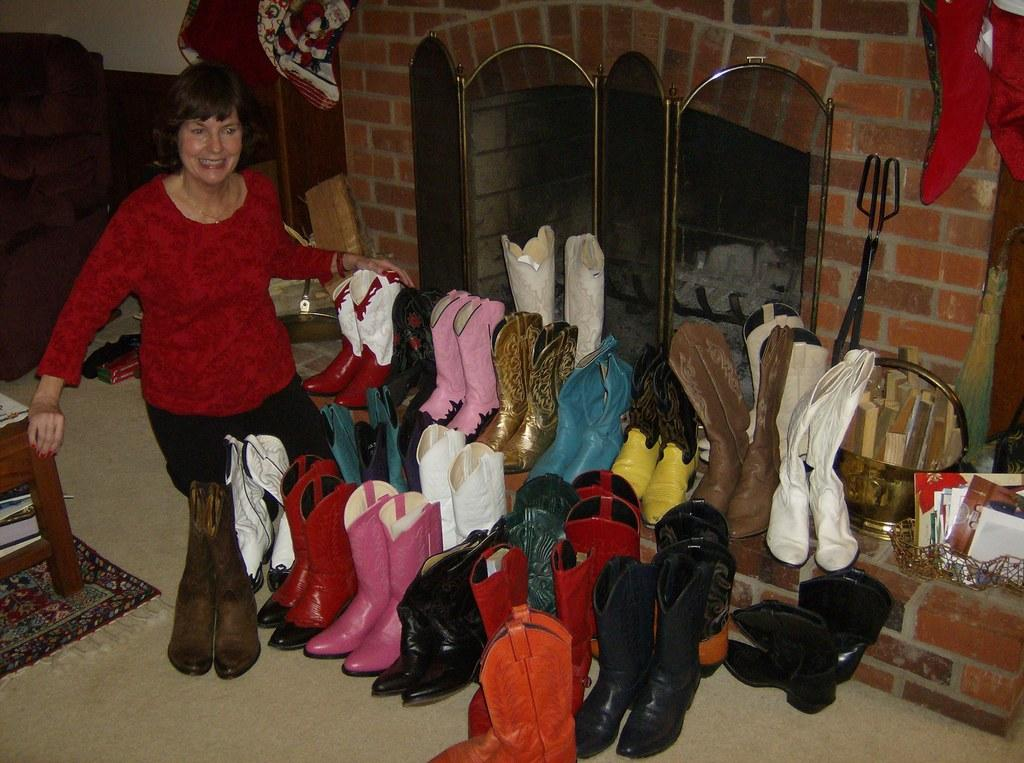What type of footwear is visible in the image? There are pairs of boots in the image. Who arranged the boots in the image? The boots are arranged by a woman. What else can be seen in the image besides the boots? There are objects around the boots. What is visible in the background of the image? There is a fireplace in the background of the image. What type of corn is being cooked in the fireplace in the image? There is no corn present in the image; the background features a fireplace, but no food is visible. 